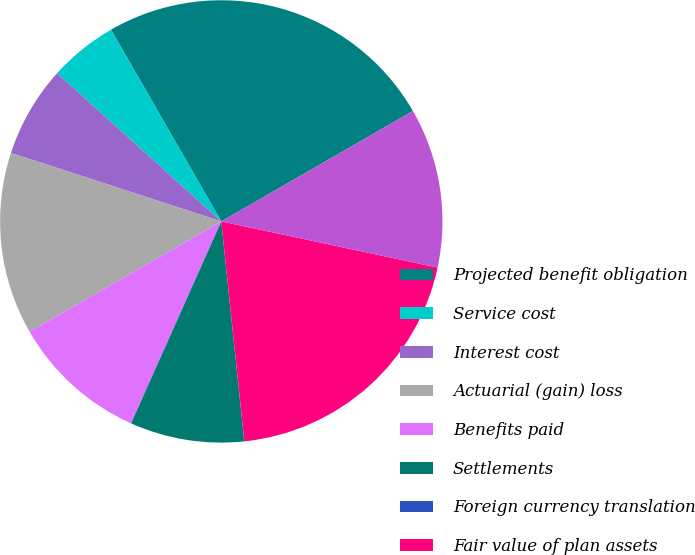Convert chart to OTSL. <chart><loc_0><loc_0><loc_500><loc_500><pie_chart><fcel>Projected benefit obligation<fcel>Service cost<fcel>Interest cost<fcel>Actuarial (gain) loss<fcel>Benefits paid<fcel>Settlements<fcel>Foreign currency translation<fcel>Fair value of plan assets<fcel>Actual return on plan assets<nl><fcel>24.99%<fcel>5.01%<fcel>6.67%<fcel>13.33%<fcel>10.0%<fcel>8.34%<fcel>0.01%<fcel>19.99%<fcel>11.67%<nl></chart> 